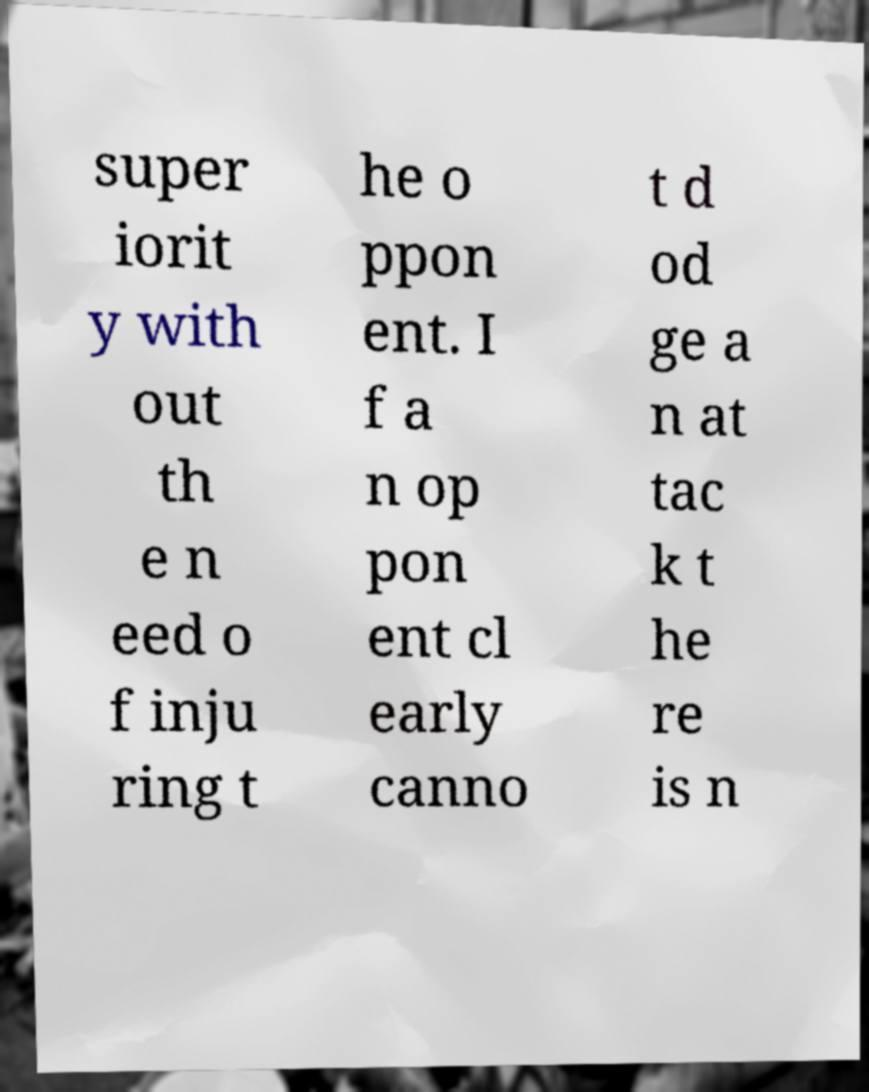Could you extract and type out the text from this image? super iorit y with out th e n eed o f inju ring t he o ppon ent. I f a n op pon ent cl early canno t d od ge a n at tac k t he re is n 